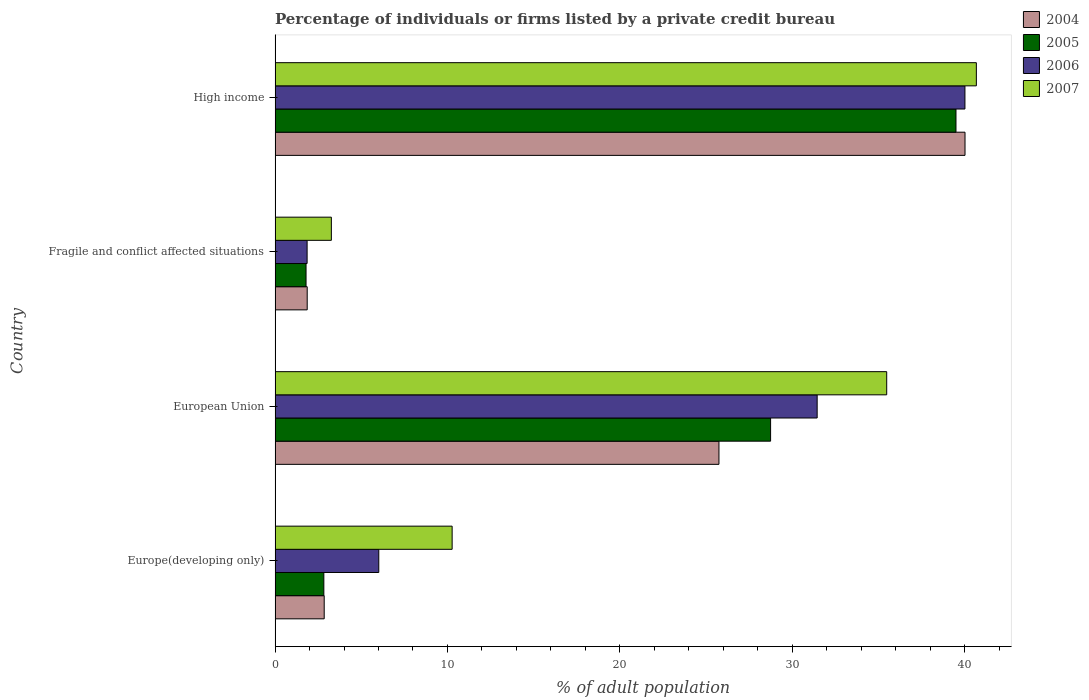Are the number of bars per tick equal to the number of legend labels?
Offer a terse response. Yes. Are the number of bars on each tick of the Y-axis equal?
Make the answer very short. Yes. How many bars are there on the 1st tick from the top?
Ensure brevity in your answer.  4. How many bars are there on the 4th tick from the bottom?
Your response must be concise. 4. What is the label of the 2nd group of bars from the top?
Your answer should be compact. Fragile and conflict affected situations. In how many cases, is the number of bars for a given country not equal to the number of legend labels?
Give a very brief answer. 0. What is the percentage of population listed by a private credit bureau in 2004 in European Union?
Ensure brevity in your answer.  25.75. Across all countries, what is the maximum percentage of population listed by a private credit bureau in 2006?
Offer a very short reply. 40.02. Across all countries, what is the minimum percentage of population listed by a private credit bureau in 2007?
Make the answer very short. 3.27. In which country was the percentage of population listed by a private credit bureau in 2007 maximum?
Offer a very short reply. High income. In which country was the percentage of population listed by a private credit bureau in 2004 minimum?
Provide a short and direct response. Fragile and conflict affected situations. What is the total percentage of population listed by a private credit bureau in 2004 in the graph?
Ensure brevity in your answer.  70.49. What is the difference between the percentage of population listed by a private credit bureau in 2005 in Fragile and conflict affected situations and that in High income?
Make the answer very short. -37.71. What is the difference between the percentage of population listed by a private credit bureau in 2006 in High income and the percentage of population listed by a private credit bureau in 2005 in European Union?
Provide a succinct answer. 11.28. What is the average percentage of population listed by a private credit bureau in 2004 per country?
Offer a terse response. 17.62. What is the difference between the percentage of population listed by a private credit bureau in 2005 and percentage of population listed by a private credit bureau in 2006 in Europe(developing only)?
Provide a short and direct response. -3.19. In how many countries, is the percentage of population listed by a private credit bureau in 2004 greater than 38 %?
Offer a very short reply. 1. What is the ratio of the percentage of population listed by a private credit bureau in 2005 in Europe(developing only) to that in Fragile and conflict affected situations?
Provide a short and direct response. 1.58. What is the difference between the highest and the second highest percentage of population listed by a private credit bureau in 2004?
Your answer should be compact. 14.28. What is the difference between the highest and the lowest percentage of population listed by a private credit bureau in 2005?
Keep it short and to the point. 37.71. What does the 3rd bar from the top in Europe(developing only) represents?
Your response must be concise. 2005. Are all the bars in the graph horizontal?
Your answer should be very brief. Yes. What is the difference between two consecutive major ticks on the X-axis?
Keep it short and to the point. 10. Are the values on the major ticks of X-axis written in scientific E-notation?
Give a very brief answer. No. Does the graph contain any zero values?
Give a very brief answer. No. Does the graph contain grids?
Your answer should be compact. No. Where does the legend appear in the graph?
Ensure brevity in your answer.  Top right. How many legend labels are there?
Give a very brief answer. 4. How are the legend labels stacked?
Your answer should be very brief. Vertical. What is the title of the graph?
Make the answer very short. Percentage of individuals or firms listed by a private credit bureau. Does "1962" appear as one of the legend labels in the graph?
Offer a very short reply. No. What is the label or title of the X-axis?
Your response must be concise. % of adult population. What is the label or title of the Y-axis?
Your answer should be compact. Country. What is the % of adult population of 2004 in Europe(developing only)?
Your response must be concise. 2.85. What is the % of adult population in 2005 in Europe(developing only)?
Offer a terse response. 2.83. What is the % of adult population in 2006 in Europe(developing only)?
Ensure brevity in your answer.  6.02. What is the % of adult population of 2007 in Europe(developing only)?
Offer a terse response. 10.27. What is the % of adult population of 2004 in European Union?
Offer a very short reply. 25.75. What is the % of adult population in 2005 in European Union?
Offer a very short reply. 28.75. What is the % of adult population of 2006 in European Union?
Your answer should be compact. 31.45. What is the % of adult population in 2007 in European Union?
Make the answer very short. 35.48. What is the % of adult population of 2004 in Fragile and conflict affected situations?
Give a very brief answer. 1.86. What is the % of adult population in 2005 in Fragile and conflict affected situations?
Make the answer very short. 1.8. What is the % of adult population in 2006 in Fragile and conflict affected situations?
Provide a succinct answer. 1.86. What is the % of adult population in 2007 in Fragile and conflict affected situations?
Provide a succinct answer. 3.27. What is the % of adult population of 2004 in High income?
Provide a succinct answer. 40.03. What is the % of adult population in 2005 in High income?
Make the answer very short. 39.5. What is the % of adult population in 2006 in High income?
Your answer should be very brief. 40.02. What is the % of adult population of 2007 in High income?
Make the answer very short. 40.69. Across all countries, what is the maximum % of adult population of 2004?
Your response must be concise. 40.03. Across all countries, what is the maximum % of adult population in 2005?
Offer a very short reply. 39.5. Across all countries, what is the maximum % of adult population of 2006?
Give a very brief answer. 40.02. Across all countries, what is the maximum % of adult population in 2007?
Your answer should be compact. 40.69. Across all countries, what is the minimum % of adult population in 2004?
Offer a terse response. 1.86. Across all countries, what is the minimum % of adult population of 2005?
Your answer should be very brief. 1.8. Across all countries, what is the minimum % of adult population in 2006?
Provide a short and direct response. 1.86. Across all countries, what is the minimum % of adult population in 2007?
Provide a succinct answer. 3.27. What is the total % of adult population in 2004 in the graph?
Provide a succinct answer. 70.49. What is the total % of adult population of 2005 in the graph?
Ensure brevity in your answer.  72.88. What is the total % of adult population of 2006 in the graph?
Offer a very short reply. 79.35. What is the total % of adult population of 2007 in the graph?
Give a very brief answer. 89.71. What is the difference between the % of adult population in 2004 in Europe(developing only) and that in European Union?
Provide a succinct answer. -22.9. What is the difference between the % of adult population of 2005 in Europe(developing only) and that in European Union?
Ensure brevity in your answer.  -25.92. What is the difference between the % of adult population of 2006 in Europe(developing only) and that in European Union?
Provide a succinct answer. -25.43. What is the difference between the % of adult population of 2007 in Europe(developing only) and that in European Union?
Provide a short and direct response. -25.21. What is the difference between the % of adult population of 2004 in Europe(developing only) and that in Fragile and conflict affected situations?
Give a very brief answer. 0.99. What is the difference between the % of adult population in 2005 in Europe(developing only) and that in Fragile and conflict affected situations?
Keep it short and to the point. 1.03. What is the difference between the % of adult population in 2006 in Europe(developing only) and that in Fragile and conflict affected situations?
Give a very brief answer. 4.16. What is the difference between the % of adult population of 2007 in Europe(developing only) and that in Fragile and conflict affected situations?
Keep it short and to the point. 7.01. What is the difference between the % of adult population in 2004 in Europe(developing only) and that in High income?
Your answer should be compact. -37.18. What is the difference between the % of adult population in 2005 in Europe(developing only) and that in High income?
Provide a succinct answer. -36.67. What is the difference between the % of adult population in 2006 in Europe(developing only) and that in High income?
Make the answer very short. -34.01. What is the difference between the % of adult population in 2007 in Europe(developing only) and that in High income?
Your answer should be compact. -30.41. What is the difference between the % of adult population in 2004 in European Union and that in Fragile and conflict affected situations?
Keep it short and to the point. 23.89. What is the difference between the % of adult population of 2005 in European Union and that in Fragile and conflict affected situations?
Keep it short and to the point. 26.95. What is the difference between the % of adult population of 2006 in European Union and that in Fragile and conflict affected situations?
Provide a short and direct response. 29.59. What is the difference between the % of adult population in 2007 in European Union and that in Fragile and conflict affected situations?
Offer a very short reply. 32.22. What is the difference between the % of adult population of 2004 in European Union and that in High income?
Your answer should be very brief. -14.28. What is the difference between the % of adult population in 2005 in European Union and that in High income?
Your answer should be very brief. -10.76. What is the difference between the % of adult population in 2006 in European Union and that in High income?
Offer a very short reply. -8.57. What is the difference between the % of adult population of 2007 in European Union and that in High income?
Ensure brevity in your answer.  -5.2. What is the difference between the % of adult population of 2004 in Fragile and conflict affected situations and that in High income?
Give a very brief answer. -38.16. What is the difference between the % of adult population of 2005 in Fragile and conflict affected situations and that in High income?
Your answer should be compact. -37.71. What is the difference between the % of adult population in 2006 in Fragile and conflict affected situations and that in High income?
Your answer should be very brief. -38.17. What is the difference between the % of adult population of 2007 in Fragile and conflict affected situations and that in High income?
Your answer should be very brief. -37.42. What is the difference between the % of adult population of 2004 in Europe(developing only) and the % of adult population of 2005 in European Union?
Provide a succinct answer. -25.9. What is the difference between the % of adult population of 2004 in Europe(developing only) and the % of adult population of 2006 in European Union?
Your response must be concise. -28.6. What is the difference between the % of adult population in 2004 in Europe(developing only) and the % of adult population in 2007 in European Union?
Provide a short and direct response. -32.63. What is the difference between the % of adult population of 2005 in Europe(developing only) and the % of adult population of 2006 in European Union?
Your answer should be very brief. -28.62. What is the difference between the % of adult population in 2005 in Europe(developing only) and the % of adult population in 2007 in European Union?
Your response must be concise. -32.66. What is the difference between the % of adult population of 2006 in Europe(developing only) and the % of adult population of 2007 in European Union?
Give a very brief answer. -29.47. What is the difference between the % of adult population of 2004 in Europe(developing only) and the % of adult population of 2005 in Fragile and conflict affected situations?
Your answer should be compact. 1.05. What is the difference between the % of adult population of 2004 in Europe(developing only) and the % of adult population of 2007 in Fragile and conflict affected situations?
Ensure brevity in your answer.  -0.42. What is the difference between the % of adult population in 2005 in Europe(developing only) and the % of adult population in 2006 in Fragile and conflict affected situations?
Make the answer very short. 0.97. What is the difference between the % of adult population in 2005 in Europe(developing only) and the % of adult population in 2007 in Fragile and conflict affected situations?
Keep it short and to the point. -0.44. What is the difference between the % of adult population of 2006 in Europe(developing only) and the % of adult population of 2007 in Fragile and conflict affected situations?
Offer a terse response. 2.75. What is the difference between the % of adult population in 2004 in Europe(developing only) and the % of adult population in 2005 in High income?
Keep it short and to the point. -36.65. What is the difference between the % of adult population in 2004 in Europe(developing only) and the % of adult population in 2006 in High income?
Your answer should be compact. -37.17. What is the difference between the % of adult population in 2004 in Europe(developing only) and the % of adult population in 2007 in High income?
Provide a succinct answer. -37.84. What is the difference between the % of adult population in 2005 in Europe(developing only) and the % of adult population in 2006 in High income?
Offer a terse response. -37.19. What is the difference between the % of adult population of 2005 in Europe(developing only) and the % of adult population of 2007 in High income?
Your answer should be compact. -37.86. What is the difference between the % of adult population in 2006 in Europe(developing only) and the % of adult population in 2007 in High income?
Your answer should be compact. -34.67. What is the difference between the % of adult population of 2004 in European Union and the % of adult population of 2005 in Fragile and conflict affected situations?
Give a very brief answer. 23.96. What is the difference between the % of adult population of 2004 in European Union and the % of adult population of 2006 in Fragile and conflict affected situations?
Keep it short and to the point. 23.89. What is the difference between the % of adult population in 2004 in European Union and the % of adult population in 2007 in Fragile and conflict affected situations?
Your answer should be very brief. 22.49. What is the difference between the % of adult population in 2005 in European Union and the % of adult population in 2006 in Fragile and conflict affected situations?
Offer a terse response. 26.89. What is the difference between the % of adult population in 2005 in European Union and the % of adult population in 2007 in Fragile and conflict affected situations?
Your answer should be compact. 25.48. What is the difference between the % of adult population in 2006 in European Union and the % of adult population in 2007 in Fragile and conflict affected situations?
Provide a succinct answer. 28.18. What is the difference between the % of adult population in 2004 in European Union and the % of adult population in 2005 in High income?
Ensure brevity in your answer.  -13.75. What is the difference between the % of adult population in 2004 in European Union and the % of adult population in 2006 in High income?
Give a very brief answer. -14.27. What is the difference between the % of adult population in 2004 in European Union and the % of adult population in 2007 in High income?
Provide a short and direct response. -14.93. What is the difference between the % of adult population in 2005 in European Union and the % of adult population in 2006 in High income?
Keep it short and to the point. -11.28. What is the difference between the % of adult population in 2005 in European Union and the % of adult population in 2007 in High income?
Make the answer very short. -11.94. What is the difference between the % of adult population in 2006 in European Union and the % of adult population in 2007 in High income?
Ensure brevity in your answer.  -9.24. What is the difference between the % of adult population in 2004 in Fragile and conflict affected situations and the % of adult population in 2005 in High income?
Your answer should be compact. -37.64. What is the difference between the % of adult population of 2004 in Fragile and conflict affected situations and the % of adult population of 2006 in High income?
Offer a very short reply. -38.16. What is the difference between the % of adult population of 2004 in Fragile and conflict affected situations and the % of adult population of 2007 in High income?
Offer a very short reply. -38.82. What is the difference between the % of adult population in 2005 in Fragile and conflict affected situations and the % of adult population in 2006 in High income?
Make the answer very short. -38.23. What is the difference between the % of adult population in 2005 in Fragile and conflict affected situations and the % of adult population in 2007 in High income?
Ensure brevity in your answer.  -38.89. What is the difference between the % of adult population in 2006 in Fragile and conflict affected situations and the % of adult population in 2007 in High income?
Offer a very short reply. -38.83. What is the average % of adult population of 2004 per country?
Ensure brevity in your answer.  17.62. What is the average % of adult population of 2005 per country?
Give a very brief answer. 18.22. What is the average % of adult population of 2006 per country?
Your response must be concise. 19.84. What is the average % of adult population in 2007 per country?
Make the answer very short. 22.43. What is the difference between the % of adult population in 2004 and % of adult population in 2005 in Europe(developing only)?
Your response must be concise. 0.02. What is the difference between the % of adult population in 2004 and % of adult population in 2006 in Europe(developing only)?
Keep it short and to the point. -3.17. What is the difference between the % of adult population in 2004 and % of adult population in 2007 in Europe(developing only)?
Ensure brevity in your answer.  -7.42. What is the difference between the % of adult population in 2005 and % of adult population in 2006 in Europe(developing only)?
Offer a terse response. -3.19. What is the difference between the % of adult population of 2005 and % of adult population of 2007 in Europe(developing only)?
Provide a succinct answer. -7.44. What is the difference between the % of adult population in 2006 and % of adult population in 2007 in Europe(developing only)?
Your answer should be very brief. -4.26. What is the difference between the % of adult population of 2004 and % of adult population of 2005 in European Union?
Provide a short and direct response. -3. What is the difference between the % of adult population in 2004 and % of adult population in 2006 in European Union?
Your response must be concise. -5.7. What is the difference between the % of adult population in 2004 and % of adult population in 2007 in European Union?
Provide a succinct answer. -9.73. What is the difference between the % of adult population in 2005 and % of adult population in 2006 in European Union?
Your response must be concise. -2.7. What is the difference between the % of adult population in 2005 and % of adult population in 2007 in European Union?
Your answer should be compact. -6.74. What is the difference between the % of adult population of 2006 and % of adult population of 2007 in European Union?
Your answer should be very brief. -4.03. What is the difference between the % of adult population of 2004 and % of adult population of 2005 in Fragile and conflict affected situations?
Offer a terse response. 0.07. What is the difference between the % of adult population in 2004 and % of adult population in 2006 in Fragile and conflict affected situations?
Offer a very short reply. 0.01. What is the difference between the % of adult population in 2004 and % of adult population in 2007 in Fragile and conflict affected situations?
Your answer should be very brief. -1.4. What is the difference between the % of adult population in 2005 and % of adult population in 2006 in Fragile and conflict affected situations?
Offer a very short reply. -0.06. What is the difference between the % of adult population in 2005 and % of adult population in 2007 in Fragile and conflict affected situations?
Make the answer very short. -1.47. What is the difference between the % of adult population of 2006 and % of adult population of 2007 in Fragile and conflict affected situations?
Keep it short and to the point. -1.41. What is the difference between the % of adult population in 2004 and % of adult population in 2005 in High income?
Offer a terse response. 0.52. What is the difference between the % of adult population in 2004 and % of adult population in 2006 in High income?
Give a very brief answer. 0. What is the difference between the % of adult population in 2004 and % of adult population in 2007 in High income?
Offer a very short reply. -0.66. What is the difference between the % of adult population in 2005 and % of adult population in 2006 in High income?
Keep it short and to the point. -0.52. What is the difference between the % of adult population in 2005 and % of adult population in 2007 in High income?
Offer a very short reply. -1.18. What is the difference between the % of adult population in 2006 and % of adult population in 2007 in High income?
Provide a short and direct response. -0.66. What is the ratio of the % of adult population in 2004 in Europe(developing only) to that in European Union?
Offer a very short reply. 0.11. What is the ratio of the % of adult population in 2005 in Europe(developing only) to that in European Union?
Your answer should be very brief. 0.1. What is the ratio of the % of adult population of 2006 in Europe(developing only) to that in European Union?
Provide a short and direct response. 0.19. What is the ratio of the % of adult population of 2007 in Europe(developing only) to that in European Union?
Keep it short and to the point. 0.29. What is the ratio of the % of adult population in 2004 in Europe(developing only) to that in Fragile and conflict affected situations?
Ensure brevity in your answer.  1.53. What is the ratio of the % of adult population of 2005 in Europe(developing only) to that in Fragile and conflict affected situations?
Provide a short and direct response. 1.57. What is the ratio of the % of adult population in 2006 in Europe(developing only) to that in Fragile and conflict affected situations?
Give a very brief answer. 3.24. What is the ratio of the % of adult population of 2007 in Europe(developing only) to that in Fragile and conflict affected situations?
Keep it short and to the point. 3.15. What is the ratio of the % of adult population in 2004 in Europe(developing only) to that in High income?
Your answer should be compact. 0.07. What is the ratio of the % of adult population of 2005 in Europe(developing only) to that in High income?
Offer a very short reply. 0.07. What is the ratio of the % of adult population in 2006 in Europe(developing only) to that in High income?
Offer a very short reply. 0.15. What is the ratio of the % of adult population in 2007 in Europe(developing only) to that in High income?
Your response must be concise. 0.25. What is the ratio of the % of adult population in 2004 in European Union to that in Fragile and conflict affected situations?
Make the answer very short. 13.82. What is the ratio of the % of adult population in 2005 in European Union to that in Fragile and conflict affected situations?
Make the answer very short. 16. What is the ratio of the % of adult population of 2006 in European Union to that in Fragile and conflict affected situations?
Provide a succinct answer. 16.92. What is the ratio of the % of adult population of 2007 in European Union to that in Fragile and conflict affected situations?
Offer a very short reply. 10.87. What is the ratio of the % of adult population of 2004 in European Union to that in High income?
Make the answer very short. 0.64. What is the ratio of the % of adult population in 2005 in European Union to that in High income?
Give a very brief answer. 0.73. What is the ratio of the % of adult population of 2006 in European Union to that in High income?
Your answer should be very brief. 0.79. What is the ratio of the % of adult population of 2007 in European Union to that in High income?
Keep it short and to the point. 0.87. What is the ratio of the % of adult population in 2004 in Fragile and conflict affected situations to that in High income?
Your answer should be compact. 0.05. What is the ratio of the % of adult population in 2005 in Fragile and conflict affected situations to that in High income?
Make the answer very short. 0.05. What is the ratio of the % of adult population in 2006 in Fragile and conflict affected situations to that in High income?
Ensure brevity in your answer.  0.05. What is the ratio of the % of adult population in 2007 in Fragile and conflict affected situations to that in High income?
Give a very brief answer. 0.08. What is the difference between the highest and the second highest % of adult population in 2004?
Offer a very short reply. 14.28. What is the difference between the highest and the second highest % of adult population of 2005?
Make the answer very short. 10.76. What is the difference between the highest and the second highest % of adult population in 2006?
Ensure brevity in your answer.  8.57. What is the difference between the highest and the second highest % of adult population in 2007?
Make the answer very short. 5.2. What is the difference between the highest and the lowest % of adult population of 2004?
Your answer should be compact. 38.16. What is the difference between the highest and the lowest % of adult population of 2005?
Your answer should be compact. 37.71. What is the difference between the highest and the lowest % of adult population of 2006?
Your answer should be very brief. 38.17. What is the difference between the highest and the lowest % of adult population of 2007?
Give a very brief answer. 37.42. 